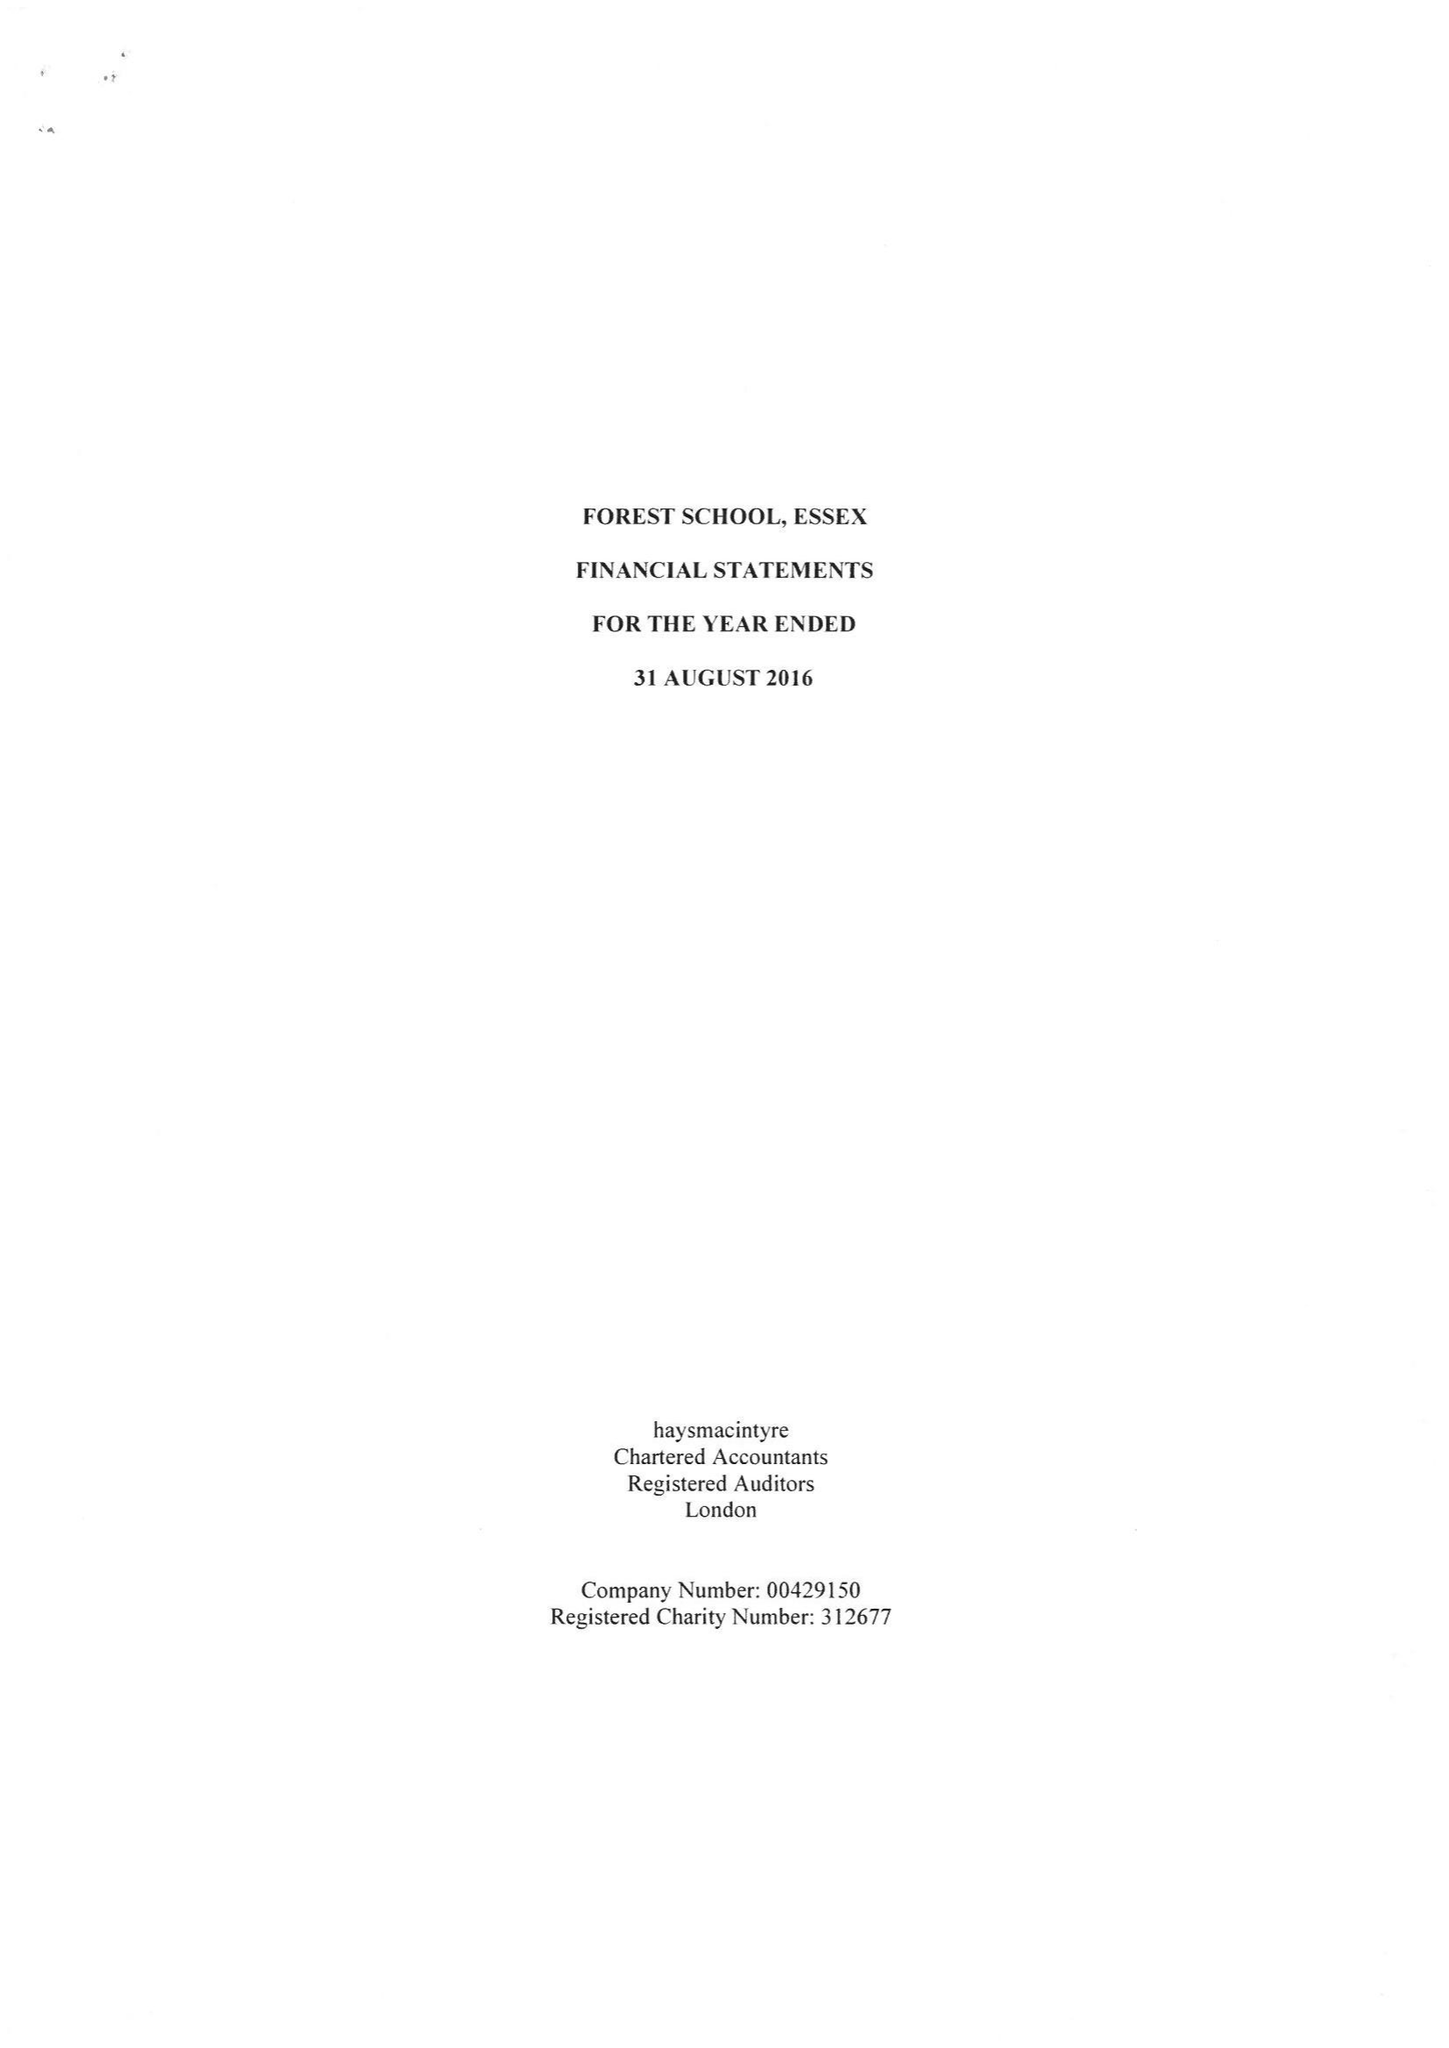What is the value for the address__post_town?
Answer the question using a single word or phrase. LONDON 